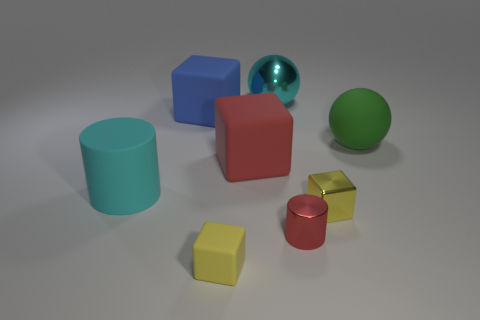The cyan shiny sphere is what size?
Your response must be concise. Large. What is the color of the block that is both in front of the big red rubber thing and to the right of the yellow matte object?
Your response must be concise. Yellow. Is the number of big green things greater than the number of large green shiny cylinders?
Give a very brief answer. Yes. What number of things are cyan objects or objects that are to the right of the large cylinder?
Make the answer very short. 8. Do the rubber cylinder and the matte sphere have the same size?
Provide a succinct answer. Yes. Are there any large green things right of the big rubber cylinder?
Your answer should be compact. Yes. How big is the object that is both in front of the small shiny block and to the right of the cyan sphere?
Make the answer very short. Small. What number of objects are either tiny balls or yellow rubber cubes?
Make the answer very short. 1. Is the size of the green object the same as the metallic object that is behind the yellow shiny thing?
Provide a succinct answer. Yes. There is a cyan cylinder that is behind the tiny yellow cube in front of the cylinder that is on the right side of the big cyan metallic thing; what is its size?
Your answer should be compact. Large. 